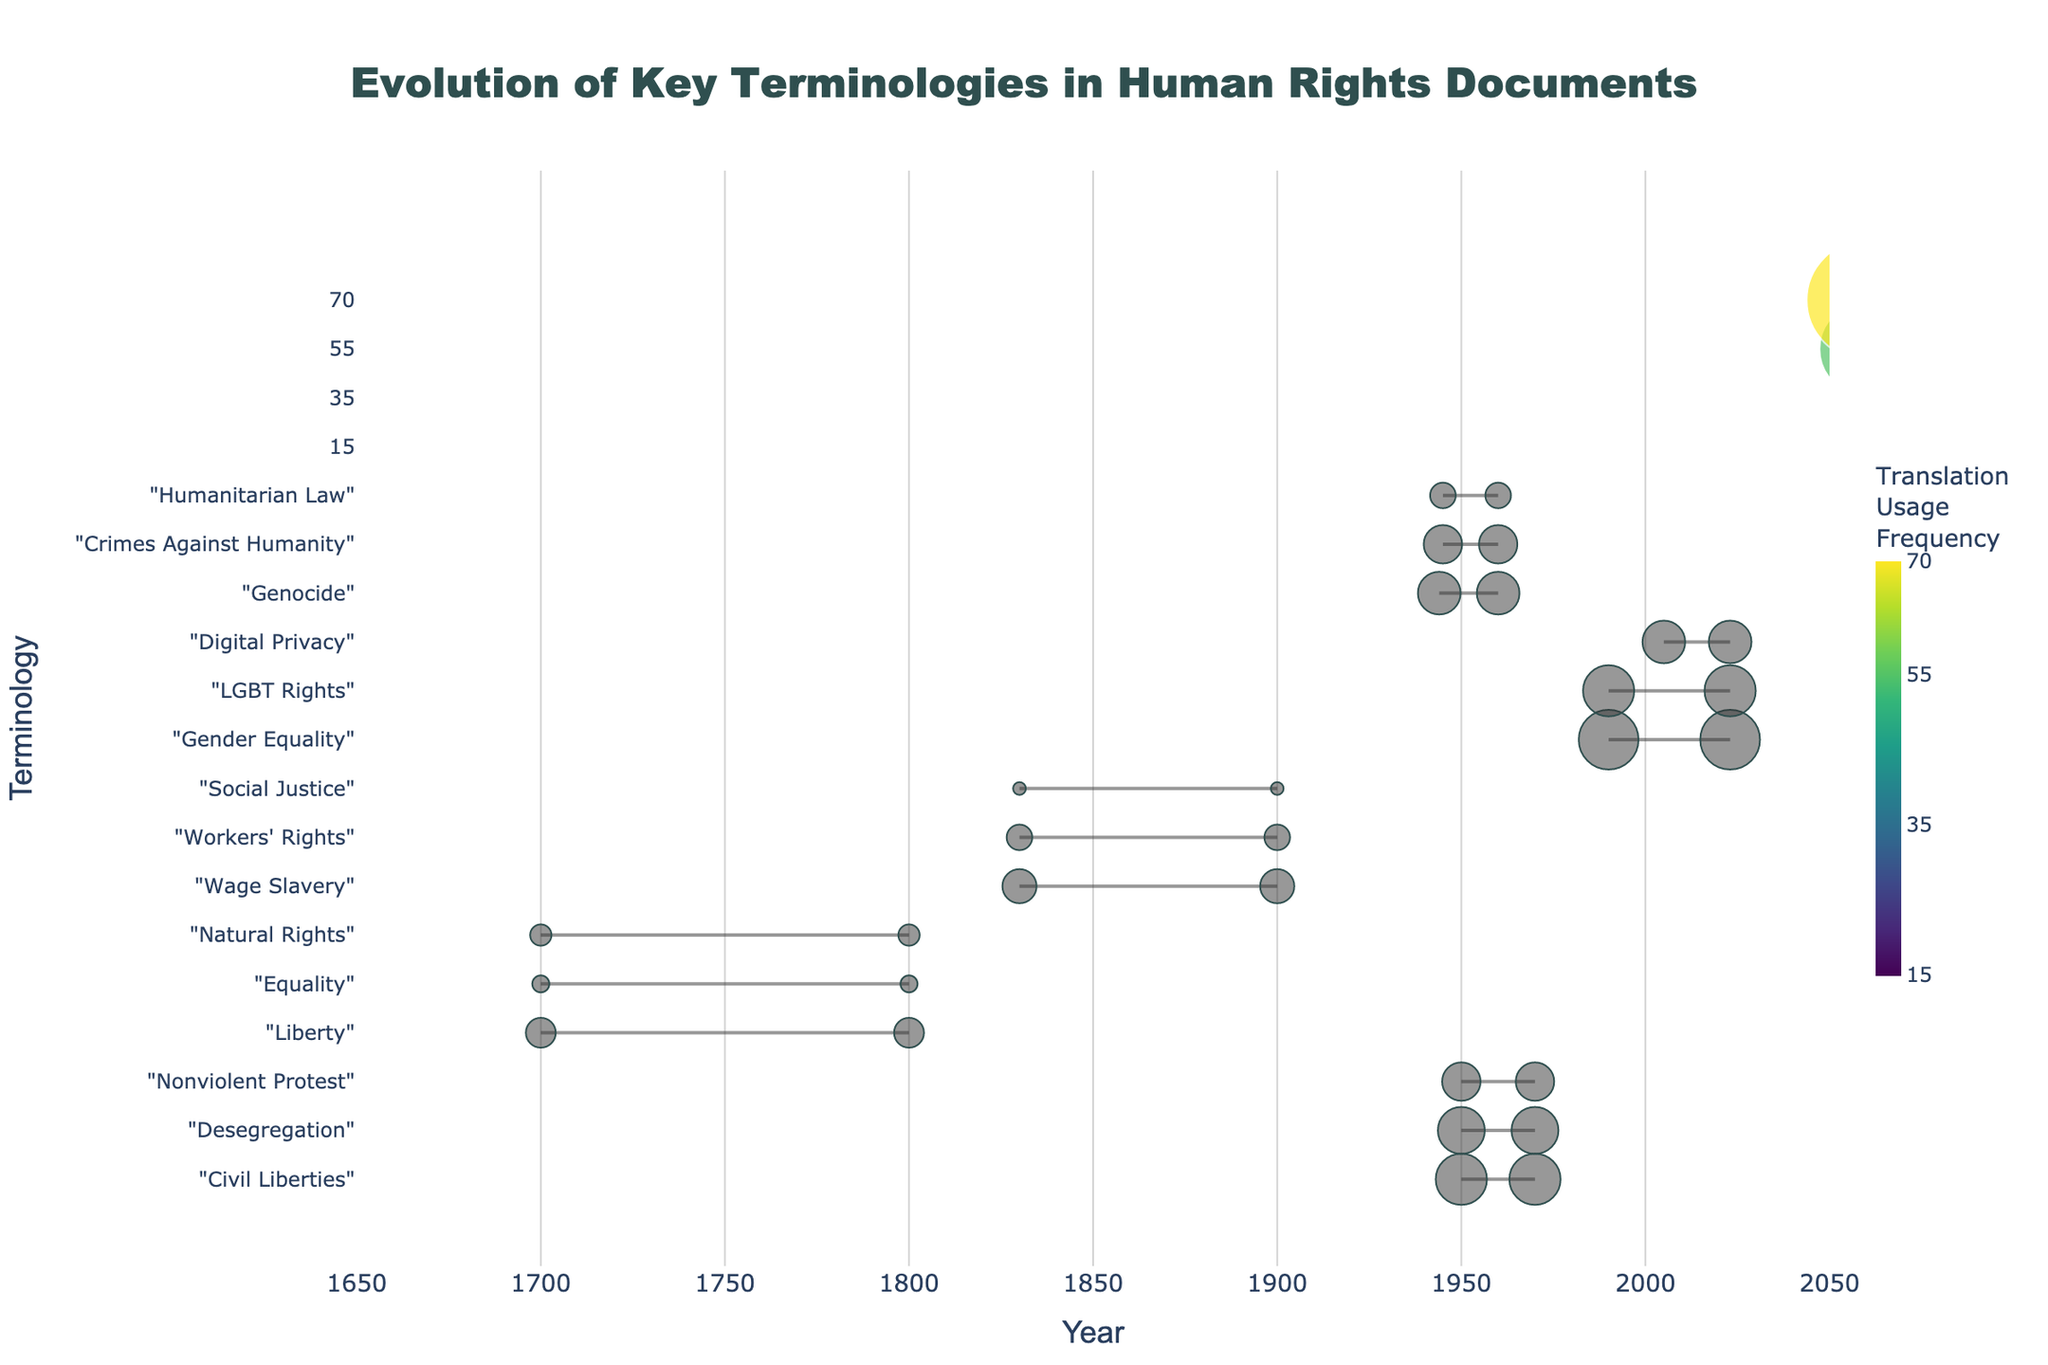What's the title of the figure? The title is usually displayed prominently at the top of the figure. Looking at the rendered figure's top, it should read "Evolution of Key Terminologies in Human Rights Documents".
Answer: Evolution of Key Terminologies in Human Rights Documents What period does the term "Workers' Rights" appear in? For the term "Workers' Rights", follow the horizontal line back to the y-axis label or look for the period label in the hover text. It falls under the "Industrial Revolution" period.
Answer: Industrial Revolution Which term from the "Modern Era" has the highest translation usage frequency? Compare the sizes of the dots corresponding to the terms in the "Modern Era" period. "Gender Equality" has the largest dot, indicating the highest frequency.
Answer: Gender Equality When did the term "Digital Privacy" first appear? Locate the term "Digital Privacy" and check the starting point of its horizontal line on the x-axis, which is labeled with the starting year. It is 2005.
Answer: 2005 How many terms appear in the "Civil Rights Movement" period? Count the number of horizontal lines under the "Civil Rights Movement" section in the y-axis. There are three terms: "Civil Liberties", "Desegregation", and "Nonviolent Protest".
Answer: 3 What's the span in years between the first and last appearance of "Genocide"? Identify the first and last appearance years for "Genocide" and calculate the difference: 1960 - 1944.
Answer: 16 years Which term between "Nonviolent Protest" and "LGBT Rights" has a higher translation usage frequency? Compare the sizes of dots for "Nonviolent Protest" and "LGBT Rights". "LGBT Rights" has a larger dot, indicating a higher frequency.
Answer: LGBT Rights Which terms were first introduced in the 1700s? Check the terms whose first appearance year falls in the 1700s. This includes "Liberty", "Equality", and "Natural Rights".
Answer: Liberty, Equality, Natural Rights What's the duration of usage for "Social Justice"? Locate the start and end years for "Social Justice" and calculate the difference. The term appears from 1830 to 1900, so 1900 - 1830 = 70 years.
Answer: 70 years Which term from the "World War II" period is associated with the highest translation usage frequency? Within the "World War II" section, find the term with the largest dot. "Genocide" has the highest frequency.
Answer: Genocide 